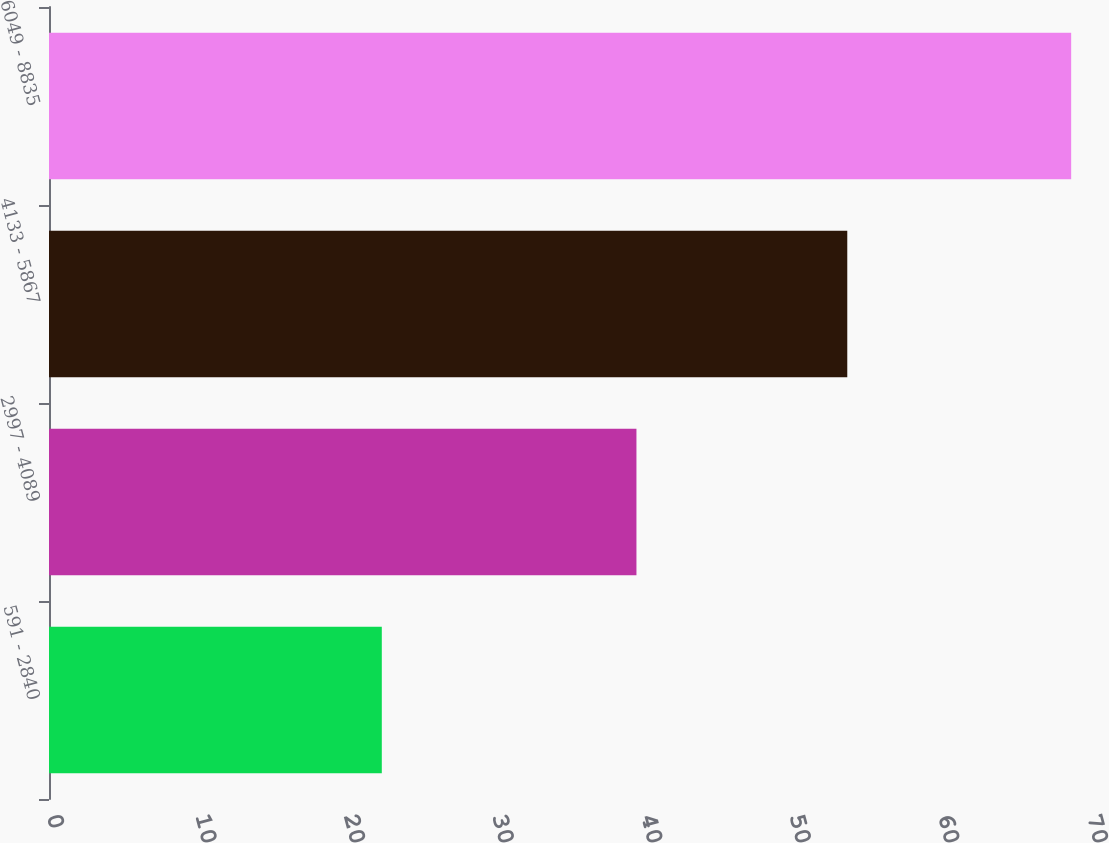Convert chart. <chart><loc_0><loc_0><loc_500><loc_500><bar_chart><fcel>591 - 2840<fcel>2997 - 4089<fcel>4133 - 5867<fcel>6049 - 8835<nl><fcel>22.4<fcel>39.54<fcel>53.73<fcel>68.8<nl></chart> 